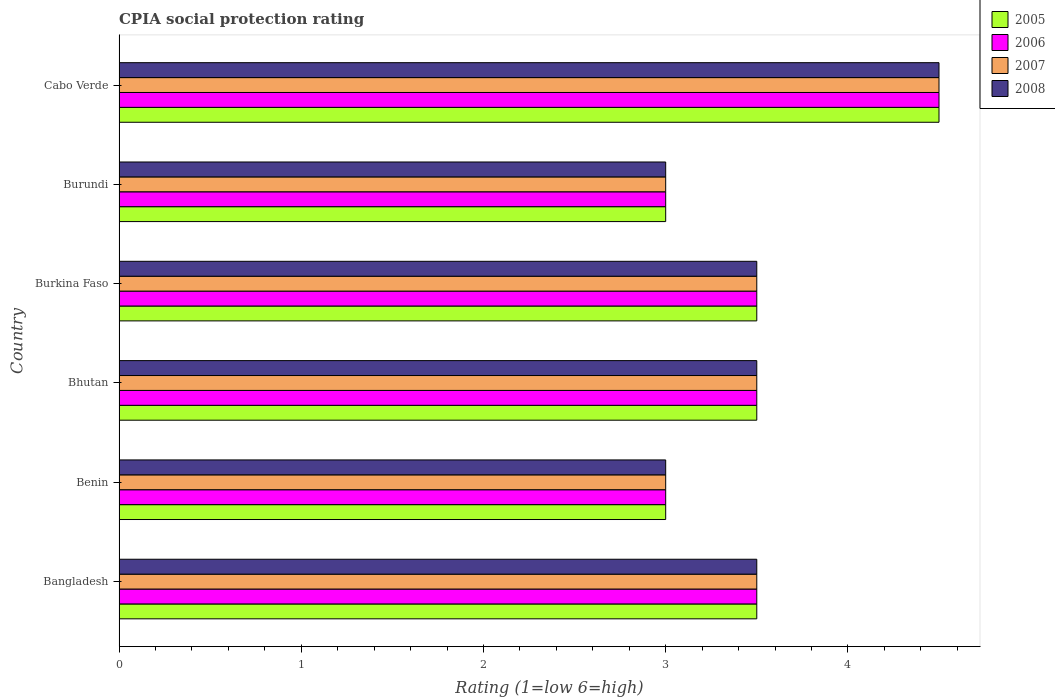How many groups of bars are there?
Your response must be concise. 6. What is the label of the 3rd group of bars from the top?
Offer a very short reply. Burkina Faso. What is the CPIA rating in 2005 in Burkina Faso?
Your answer should be compact. 3.5. Across all countries, what is the maximum CPIA rating in 2007?
Make the answer very short. 4.5. In which country was the CPIA rating in 2008 maximum?
Provide a succinct answer. Cabo Verde. In which country was the CPIA rating in 2008 minimum?
Provide a short and direct response. Benin. What is the difference between the CPIA rating in 2006 in Burundi and the CPIA rating in 2005 in Burkina Faso?
Offer a terse response. -0.5. What is the difference between the CPIA rating in 2006 and CPIA rating in 2008 in Benin?
Give a very brief answer. 0. What is the ratio of the CPIA rating in 2007 in Burundi to that in Cabo Verde?
Your response must be concise. 0.67. Is the CPIA rating in 2005 in Bangladesh less than that in Cabo Verde?
Offer a very short reply. Yes. Is the difference between the CPIA rating in 2006 in Bhutan and Cabo Verde greater than the difference between the CPIA rating in 2008 in Bhutan and Cabo Verde?
Keep it short and to the point. No. In how many countries, is the CPIA rating in 2007 greater than the average CPIA rating in 2007 taken over all countries?
Keep it short and to the point. 1. Is the sum of the CPIA rating in 2005 in Benin and Cabo Verde greater than the maximum CPIA rating in 2007 across all countries?
Provide a succinct answer. Yes. Is it the case that in every country, the sum of the CPIA rating in 2008 and CPIA rating in 2007 is greater than the sum of CPIA rating in 2006 and CPIA rating in 2005?
Your response must be concise. No. What does the 3rd bar from the bottom in Burkina Faso represents?
Offer a terse response. 2007. Is it the case that in every country, the sum of the CPIA rating in 2006 and CPIA rating in 2008 is greater than the CPIA rating in 2007?
Provide a succinct answer. Yes. How many bars are there?
Offer a terse response. 24. How many countries are there in the graph?
Give a very brief answer. 6. Are the values on the major ticks of X-axis written in scientific E-notation?
Offer a very short reply. No. Does the graph contain grids?
Your answer should be compact. No. How many legend labels are there?
Provide a short and direct response. 4. How are the legend labels stacked?
Offer a terse response. Vertical. What is the title of the graph?
Offer a terse response. CPIA social protection rating. What is the label or title of the X-axis?
Offer a terse response. Rating (1=low 6=high). What is the Rating (1=low 6=high) of 2006 in Bangladesh?
Make the answer very short. 3.5. What is the Rating (1=low 6=high) of 2007 in Bangladesh?
Provide a short and direct response. 3.5. What is the Rating (1=low 6=high) of 2005 in Benin?
Offer a very short reply. 3. What is the Rating (1=low 6=high) in 2007 in Benin?
Your response must be concise. 3. What is the Rating (1=low 6=high) of 2006 in Bhutan?
Your answer should be very brief. 3.5. What is the Rating (1=low 6=high) of 2007 in Bhutan?
Offer a terse response. 3.5. What is the Rating (1=low 6=high) in 2006 in Burkina Faso?
Provide a short and direct response. 3.5. What is the Rating (1=low 6=high) of 2008 in Burundi?
Your answer should be very brief. 3. What is the Rating (1=low 6=high) in 2005 in Cabo Verde?
Offer a very short reply. 4.5. What is the Rating (1=low 6=high) of 2007 in Cabo Verde?
Offer a very short reply. 4.5. What is the Rating (1=low 6=high) in 2008 in Cabo Verde?
Your answer should be compact. 4.5. Across all countries, what is the maximum Rating (1=low 6=high) in 2005?
Ensure brevity in your answer.  4.5. Across all countries, what is the minimum Rating (1=low 6=high) in 2005?
Provide a short and direct response. 3. What is the difference between the Rating (1=low 6=high) of 2005 in Bangladesh and that in Benin?
Keep it short and to the point. 0.5. What is the difference between the Rating (1=low 6=high) of 2007 in Bangladesh and that in Benin?
Give a very brief answer. 0.5. What is the difference between the Rating (1=low 6=high) of 2008 in Bangladesh and that in Benin?
Your answer should be compact. 0.5. What is the difference between the Rating (1=low 6=high) in 2006 in Bangladesh and that in Bhutan?
Your response must be concise. 0. What is the difference between the Rating (1=low 6=high) in 2005 in Bangladesh and that in Burkina Faso?
Make the answer very short. 0. What is the difference between the Rating (1=low 6=high) of 2006 in Bangladesh and that in Burkina Faso?
Provide a short and direct response. 0. What is the difference between the Rating (1=low 6=high) in 2005 in Bangladesh and that in Burundi?
Ensure brevity in your answer.  0.5. What is the difference between the Rating (1=low 6=high) in 2008 in Bangladesh and that in Burundi?
Provide a succinct answer. 0.5. What is the difference between the Rating (1=low 6=high) of 2006 in Bangladesh and that in Cabo Verde?
Keep it short and to the point. -1. What is the difference between the Rating (1=low 6=high) in 2007 in Bangladesh and that in Cabo Verde?
Your answer should be very brief. -1. What is the difference between the Rating (1=low 6=high) of 2007 in Benin and that in Bhutan?
Your response must be concise. -0.5. What is the difference between the Rating (1=low 6=high) in 2008 in Benin and that in Bhutan?
Keep it short and to the point. -0.5. What is the difference between the Rating (1=low 6=high) in 2005 in Benin and that in Burkina Faso?
Provide a short and direct response. -0.5. What is the difference between the Rating (1=low 6=high) of 2006 in Benin and that in Burkina Faso?
Provide a short and direct response. -0.5. What is the difference between the Rating (1=low 6=high) of 2007 in Benin and that in Burkina Faso?
Your answer should be compact. -0.5. What is the difference between the Rating (1=low 6=high) in 2005 in Benin and that in Burundi?
Your answer should be very brief. 0. What is the difference between the Rating (1=low 6=high) in 2006 in Benin and that in Burundi?
Ensure brevity in your answer.  0. What is the difference between the Rating (1=low 6=high) of 2007 in Benin and that in Burundi?
Provide a succinct answer. 0. What is the difference between the Rating (1=low 6=high) in 2007 in Benin and that in Cabo Verde?
Your response must be concise. -1.5. What is the difference between the Rating (1=low 6=high) of 2006 in Bhutan and that in Burkina Faso?
Provide a short and direct response. 0. What is the difference between the Rating (1=low 6=high) of 2007 in Bhutan and that in Burkina Faso?
Provide a succinct answer. 0. What is the difference between the Rating (1=low 6=high) in 2008 in Bhutan and that in Burkina Faso?
Your response must be concise. 0. What is the difference between the Rating (1=low 6=high) of 2005 in Bhutan and that in Burundi?
Ensure brevity in your answer.  0.5. What is the difference between the Rating (1=low 6=high) in 2006 in Bhutan and that in Burundi?
Keep it short and to the point. 0.5. What is the difference between the Rating (1=low 6=high) in 2007 in Bhutan and that in Burundi?
Make the answer very short. 0.5. What is the difference between the Rating (1=low 6=high) in 2008 in Bhutan and that in Burundi?
Your answer should be very brief. 0.5. What is the difference between the Rating (1=low 6=high) in 2005 in Burkina Faso and that in Burundi?
Offer a very short reply. 0.5. What is the difference between the Rating (1=low 6=high) in 2006 in Burkina Faso and that in Burundi?
Offer a terse response. 0.5. What is the difference between the Rating (1=low 6=high) in 2007 in Burkina Faso and that in Burundi?
Make the answer very short. 0.5. What is the difference between the Rating (1=low 6=high) of 2007 in Burkina Faso and that in Cabo Verde?
Your answer should be very brief. -1. What is the difference between the Rating (1=low 6=high) of 2005 in Burundi and that in Cabo Verde?
Give a very brief answer. -1.5. What is the difference between the Rating (1=low 6=high) in 2007 in Burundi and that in Cabo Verde?
Offer a terse response. -1.5. What is the difference between the Rating (1=low 6=high) of 2008 in Burundi and that in Cabo Verde?
Provide a short and direct response. -1.5. What is the difference between the Rating (1=low 6=high) of 2005 in Bangladesh and the Rating (1=low 6=high) of 2006 in Benin?
Provide a succinct answer. 0.5. What is the difference between the Rating (1=low 6=high) in 2006 in Bangladesh and the Rating (1=low 6=high) in 2007 in Benin?
Your answer should be compact. 0.5. What is the difference between the Rating (1=low 6=high) of 2007 in Bangladesh and the Rating (1=low 6=high) of 2008 in Benin?
Offer a terse response. 0.5. What is the difference between the Rating (1=low 6=high) of 2005 in Bangladesh and the Rating (1=low 6=high) of 2006 in Bhutan?
Provide a short and direct response. 0. What is the difference between the Rating (1=low 6=high) in 2005 in Bangladesh and the Rating (1=low 6=high) in 2007 in Bhutan?
Provide a succinct answer. 0. What is the difference between the Rating (1=low 6=high) of 2006 in Bangladesh and the Rating (1=low 6=high) of 2007 in Burkina Faso?
Ensure brevity in your answer.  0. What is the difference between the Rating (1=low 6=high) in 2005 in Bangladesh and the Rating (1=low 6=high) in 2007 in Burundi?
Your response must be concise. 0.5. What is the difference between the Rating (1=low 6=high) in 2006 in Bangladesh and the Rating (1=low 6=high) in 2008 in Burundi?
Offer a terse response. 0.5. What is the difference between the Rating (1=low 6=high) in 2007 in Bangladesh and the Rating (1=low 6=high) in 2008 in Burundi?
Make the answer very short. 0.5. What is the difference between the Rating (1=low 6=high) in 2005 in Bangladesh and the Rating (1=low 6=high) in 2007 in Cabo Verde?
Make the answer very short. -1. What is the difference between the Rating (1=low 6=high) in 2007 in Bangladesh and the Rating (1=low 6=high) in 2008 in Cabo Verde?
Provide a succinct answer. -1. What is the difference between the Rating (1=low 6=high) in 2005 in Benin and the Rating (1=low 6=high) in 2006 in Bhutan?
Ensure brevity in your answer.  -0.5. What is the difference between the Rating (1=low 6=high) in 2005 in Benin and the Rating (1=low 6=high) in 2008 in Bhutan?
Ensure brevity in your answer.  -0.5. What is the difference between the Rating (1=low 6=high) in 2006 in Benin and the Rating (1=low 6=high) in 2007 in Bhutan?
Your response must be concise. -0.5. What is the difference between the Rating (1=low 6=high) of 2006 in Benin and the Rating (1=low 6=high) of 2008 in Bhutan?
Offer a terse response. -0.5. What is the difference between the Rating (1=low 6=high) in 2006 in Benin and the Rating (1=low 6=high) in 2007 in Burkina Faso?
Provide a succinct answer. -0.5. What is the difference between the Rating (1=low 6=high) of 2006 in Benin and the Rating (1=low 6=high) of 2008 in Burkina Faso?
Give a very brief answer. -0.5. What is the difference between the Rating (1=low 6=high) of 2007 in Benin and the Rating (1=low 6=high) of 2008 in Burkina Faso?
Ensure brevity in your answer.  -0.5. What is the difference between the Rating (1=low 6=high) of 2005 in Benin and the Rating (1=low 6=high) of 2006 in Burundi?
Keep it short and to the point. 0. What is the difference between the Rating (1=low 6=high) in 2007 in Benin and the Rating (1=low 6=high) in 2008 in Burundi?
Offer a terse response. 0. What is the difference between the Rating (1=low 6=high) of 2005 in Benin and the Rating (1=low 6=high) of 2006 in Cabo Verde?
Give a very brief answer. -1.5. What is the difference between the Rating (1=low 6=high) in 2005 in Benin and the Rating (1=low 6=high) in 2007 in Cabo Verde?
Offer a terse response. -1.5. What is the difference between the Rating (1=low 6=high) of 2005 in Benin and the Rating (1=low 6=high) of 2008 in Cabo Verde?
Keep it short and to the point. -1.5. What is the difference between the Rating (1=low 6=high) of 2006 in Benin and the Rating (1=low 6=high) of 2007 in Cabo Verde?
Your answer should be very brief. -1.5. What is the difference between the Rating (1=low 6=high) in 2006 in Benin and the Rating (1=low 6=high) in 2008 in Cabo Verde?
Your response must be concise. -1.5. What is the difference between the Rating (1=low 6=high) in 2005 in Bhutan and the Rating (1=low 6=high) in 2006 in Burkina Faso?
Your answer should be very brief. 0. What is the difference between the Rating (1=low 6=high) of 2006 in Bhutan and the Rating (1=low 6=high) of 2008 in Burkina Faso?
Provide a short and direct response. 0. What is the difference between the Rating (1=low 6=high) in 2007 in Bhutan and the Rating (1=low 6=high) in 2008 in Burkina Faso?
Ensure brevity in your answer.  0. What is the difference between the Rating (1=low 6=high) of 2006 in Bhutan and the Rating (1=low 6=high) of 2007 in Burundi?
Provide a succinct answer. 0.5. What is the difference between the Rating (1=low 6=high) in 2006 in Bhutan and the Rating (1=low 6=high) in 2008 in Burundi?
Give a very brief answer. 0.5. What is the difference between the Rating (1=low 6=high) in 2007 in Bhutan and the Rating (1=low 6=high) in 2008 in Burundi?
Your answer should be compact. 0.5. What is the difference between the Rating (1=low 6=high) in 2005 in Bhutan and the Rating (1=low 6=high) in 2006 in Cabo Verde?
Provide a succinct answer. -1. What is the difference between the Rating (1=low 6=high) of 2005 in Bhutan and the Rating (1=low 6=high) of 2007 in Cabo Verde?
Give a very brief answer. -1. What is the difference between the Rating (1=low 6=high) in 2005 in Bhutan and the Rating (1=low 6=high) in 2008 in Cabo Verde?
Your response must be concise. -1. What is the difference between the Rating (1=low 6=high) in 2006 in Bhutan and the Rating (1=low 6=high) in 2007 in Cabo Verde?
Ensure brevity in your answer.  -1. What is the difference between the Rating (1=low 6=high) in 2007 in Bhutan and the Rating (1=low 6=high) in 2008 in Cabo Verde?
Provide a short and direct response. -1. What is the difference between the Rating (1=low 6=high) of 2005 in Burkina Faso and the Rating (1=low 6=high) of 2006 in Burundi?
Provide a succinct answer. 0.5. What is the difference between the Rating (1=low 6=high) in 2005 in Burkina Faso and the Rating (1=low 6=high) in 2007 in Burundi?
Keep it short and to the point. 0.5. What is the difference between the Rating (1=low 6=high) in 2005 in Burkina Faso and the Rating (1=low 6=high) in 2008 in Burundi?
Provide a short and direct response. 0.5. What is the difference between the Rating (1=low 6=high) of 2007 in Burkina Faso and the Rating (1=low 6=high) of 2008 in Burundi?
Provide a succinct answer. 0.5. What is the difference between the Rating (1=low 6=high) in 2005 in Burkina Faso and the Rating (1=low 6=high) in 2006 in Cabo Verde?
Make the answer very short. -1. What is the difference between the Rating (1=low 6=high) of 2005 in Burkina Faso and the Rating (1=low 6=high) of 2007 in Cabo Verde?
Make the answer very short. -1. What is the difference between the Rating (1=low 6=high) of 2006 in Burkina Faso and the Rating (1=low 6=high) of 2008 in Cabo Verde?
Give a very brief answer. -1. What is the difference between the Rating (1=low 6=high) in 2005 in Burundi and the Rating (1=low 6=high) in 2006 in Cabo Verde?
Ensure brevity in your answer.  -1.5. What is the difference between the Rating (1=low 6=high) of 2005 in Burundi and the Rating (1=low 6=high) of 2007 in Cabo Verde?
Provide a short and direct response. -1.5. What is the difference between the Rating (1=low 6=high) in 2005 in Burundi and the Rating (1=low 6=high) in 2008 in Cabo Verde?
Your response must be concise. -1.5. What is the difference between the Rating (1=low 6=high) of 2006 in Burundi and the Rating (1=low 6=high) of 2007 in Cabo Verde?
Your answer should be compact. -1.5. What is the average Rating (1=low 6=high) in 2006 per country?
Ensure brevity in your answer.  3.5. What is the average Rating (1=low 6=high) in 2008 per country?
Offer a very short reply. 3.5. What is the difference between the Rating (1=low 6=high) of 2005 and Rating (1=low 6=high) of 2007 in Bangladesh?
Offer a terse response. 0. What is the difference between the Rating (1=low 6=high) in 2005 and Rating (1=low 6=high) in 2008 in Bangladesh?
Your answer should be very brief. 0. What is the difference between the Rating (1=low 6=high) of 2006 and Rating (1=low 6=high) of 2007 in Bangladesh?
Provide a short and direct response. 0. What is the difference between the Rating (1=low 6=high) in 2006 and Rating (1=low 6=high) in 2008 in Bangladesh?
Make the answer very short. 0. What is the difference between the Rating (1=low 6=high) of 2005 and Rating (1=low 6=high) of 2008 in Benin?
Ensure brevity in your answer.  0. What is the difference between the Rating (1=low 6=high) in 2006 and Rating (1=low 6=high) in 2007 in Benin?
Keep it short and to the point. 0. What is the difference between the Rating (1=low 6=high) of 2006 and Rating (1=low 6=high) of 2008 in Benin?
Your answer should be very brief. 0. What is the difference between the Rating (1=low 6=high) of 2005 and Rating (1=low 6=high) of 2006 in Bhutan?
Make the answer very short. 0. What is the difference between the Rating (1=low 6=high) in 2005 and Rating (1=low 6=high) in 2008 in Bhutan?
Your answer should be very brief. 0. What is the difference between the Rating (1=low 6=high) of 2006 and Rating (1=low 6=high) of 2007 in Bhutan?
Keep it short and to the point. 0. What is the difference between the Rating (1=low 6=high) of 2006 and Rating (1=low 6=high) of 2008 in Bhutan?
Give a very brief answer. 0. What is the difference between the Rating (1=low 6=high) in 2007 and Rating (1=low 6=high) in 2008 in Bhutan?
Provide a succinct answer. 0. What is the difference between the Rating (1=low 6=high) of 2005 and Rating (1=low 6=high) of 2006 in Burkina Faso?
Keep it short and to the point. 0. What is the difference between the Rating (1=low 6=high) in 2005 and Rating (1=low 6=high) in 2007 in Burkina Faso?
Your response must be concise. 0. What is the difference between the Rating (1=low 6=high) in 2006 and Rating (1=low 6=high) in 2007 in Burkina Faso?
Keep it short and to the point. 0. What is the difference between the Rating (1=low 6=high) in 2006 and Rating (1=low 6=high) in 2008 in Burkina Faso?
Keep it short and to the point. 0. What is the difference between the Rating (1=low 6=high) of 2005 and Rating (1=low 6=high) of 2007 in Burundi?
Offer a terse response. 0. What is the difference between the Rating (1=low 6=high) of 2005 and Rating (1=low 6=high) of 2008 in Burundi?
Provide a short and direct response. 0. What is the difference between the Rating (1=low 6=high) of 2007 and Rating (1=low 6=high) of 2008 in Burundi?
Your response must be concise. 0. What is the difference between the Rating (1=low 6=high) of 2005 and Rating (1=low 6=high) of 2007 in Cabo Verde?
Provide a short and direct response. 0. What is the difference between the Rating (1=low 6=high) in 2005 and Rating (1=low 6=high) in 2008 in Cabo Verde?
Offer a very short reply. 0. What is the difference between the Rating (1=low 6=high) of 2006 and Rating (1=low 6=high) of 2008 in Cabo Verde?
Keep it short and to the point. 0. What is the difference between the Rating (1=low 6=high) in 2007 and Rating (1=low 6=high) in 2008 in Cabo Verde?
Ensure brevity in your answer.  0. What is the ratio of the Rating (1=low 6=high) in 2007 in Bangladesh to that in Benin?
Your answer should be very brief. 1.17. What is the ratio of the Rating (1=low 6=high) of 2008 in Bangladesh to that in Benin?
Give a very brief answer. 1.17. What is the ratio of the Rating (1=low 6=high) in 2005 in Bangladesh to that in Bhutan?
Ensure brevity in your answer.  1. What is the ratio of the Rating (1=low 6=high) of 2005 in Bangladesh to that in Burkina Faso?
Offer a very short reply. 1. What is the ratio of the Rating (1=low 6=high) in 2006 in Bangladesh to that in Burkina Faso?
Your answer should be compact. 1. What is the ratio of the Rating (1=low 6=high) in 2006 in Bangladesh to that in Burundi?
Ensure brevity in your answer.  1.17. What is the ratio of the Rating (1=low 6=high) in 2007 in Bangladesh to that in Burundi?
Offer a very short reply. 1.17. What is the ratio of the Rating (1=low 6=high) of 2005 in Bangladesh to that in Cabo Verde?
Give a very brief answer. 0.78. What is the ratio of the Rating (1=low 6=high) in 2007 in Bangladesh to that in Cabo Verde?
Keep it short and to the point. 0.78. What is the ratio of the Rating (1=low 6=high) of 2005 in Benin to that in Bhutan?
Ensure brevity in your answer.  0.86. What is the ratio of the Rating (1=low 6=high) of 2007 in Benin to that in Bhutan?
Your answer should be very brief. 0.86. What is the ratio of the Rating (1=low 6=high) of 2005 in Benin to that in Burkina Faso?
Your answer should be compact. 0.86. What is the ratio of the Rating (1=low 6=high) in 2007 in Benin to that in Burkina Faso?
Provide a short and direct response. 0.86. What is the ratio of the Rating (1=low 6=high) of 2006 in Benin to that in Burundi?
Your response must be concise. 1. What is the ratio of the Rating (1=low 6=high) of 2007 in Benin to that in Burundi?
Offer a terse response. 1. What is the ratio of the Rating (1=low 6=high) of 2005 in Benin to that in Cabo Verde?
Your answer should be very brief. 0.67. What is the ratio of the Rating (1=low 6=high) in 2006 in Bhutan to that in Burkina Faso?
Offer a very short reply. 1. What is the ratio of the Rating (1=low 6=high) in 2006 in Bhutan to that in Burundi?
Make the answer very short. 1.17. What is the ratio of the Rating (1=low 6=high) in 2007 in Bhutan to that in Burundi?
Your answer should be very brief. 1.17. What is the ratio of the Rating (1=low 6=high) in 2008 in Bhutan to that in Burundi?
Your answer should be very brief. 1.17. What is the ratio of the Rating (1=low 6=high) in 2006 in Bhutan to that in Cabo Verde?
Your answer should be very brief. 0.78. What is the ratio of the Rating (1=low 6=high) of 2007 in Bhutan to that in Cabo Verde?
Offer a terse response. 0.78. What is the ratio of the Rating (1=low 6=high) of 2008 in Bhutan to that in Cabo Verde?
Offer a very short reply. 0.78. What is the ratio of the Rating (1=low 6=high) of 2006 in Burkina Faso to that in Burundi?
Offer a terse response. 1.17. What is the ratio of the Rating (1=low 6=high) in 2007 in Burkina Faso to that in Burundi?
Your response must be concise. 1.17. What is the ratio of the Rating (1=low 6=high) of 2008 in Burkina Faso to that in Burundi?
Keep it short and to the point. 1.17. What is the ratio of the Rating (1=low 6=high) of 2006 in Burkina Faso to that in Cabo Verde?
Your answer should be very brief. 0.78. What is the ratio of the Rating (1=low 6=high) of 2007 in Burkina Faso to that in Cabo Verde?
Offer a very short reply. 0.78. What is the ratio of the Rating (1=low 6=high) in 2008 in Burkina Faso to that in Cabo Verde?
Keep it short and to the point. 0.78. What is the ratio of the Rating (1=low 6=high) in 2005 in Burundi to that in Cabo Verde?
Your response must be concise. 0.67. What is the ratio of the Rating (1=low 6=high) in 2007 in Burundi to that in Cabo Verde?
Offer a very short reply. 0.67. What is the difference between the highest and the second highest Rating (1=low 6=high) of 2006?
Provide a succinct answer. 1. What is the difference between the highest and the second highest Rating (1=low 6=high) in 2008?
Offer a very short reply. 1. What is the difference between the highest and the lowest Rating (1=low 6=high) in 2006?
Your answer should be very brief. 1.5. What is the difference between the highest and the lowest Rating (1=low 6=high) in 2007?
Your response must be concise. 1.5. What is the difference between the highest and the lowest Rating (1=low 6=high) of 2008?
Offer a terse response. 1.5. 